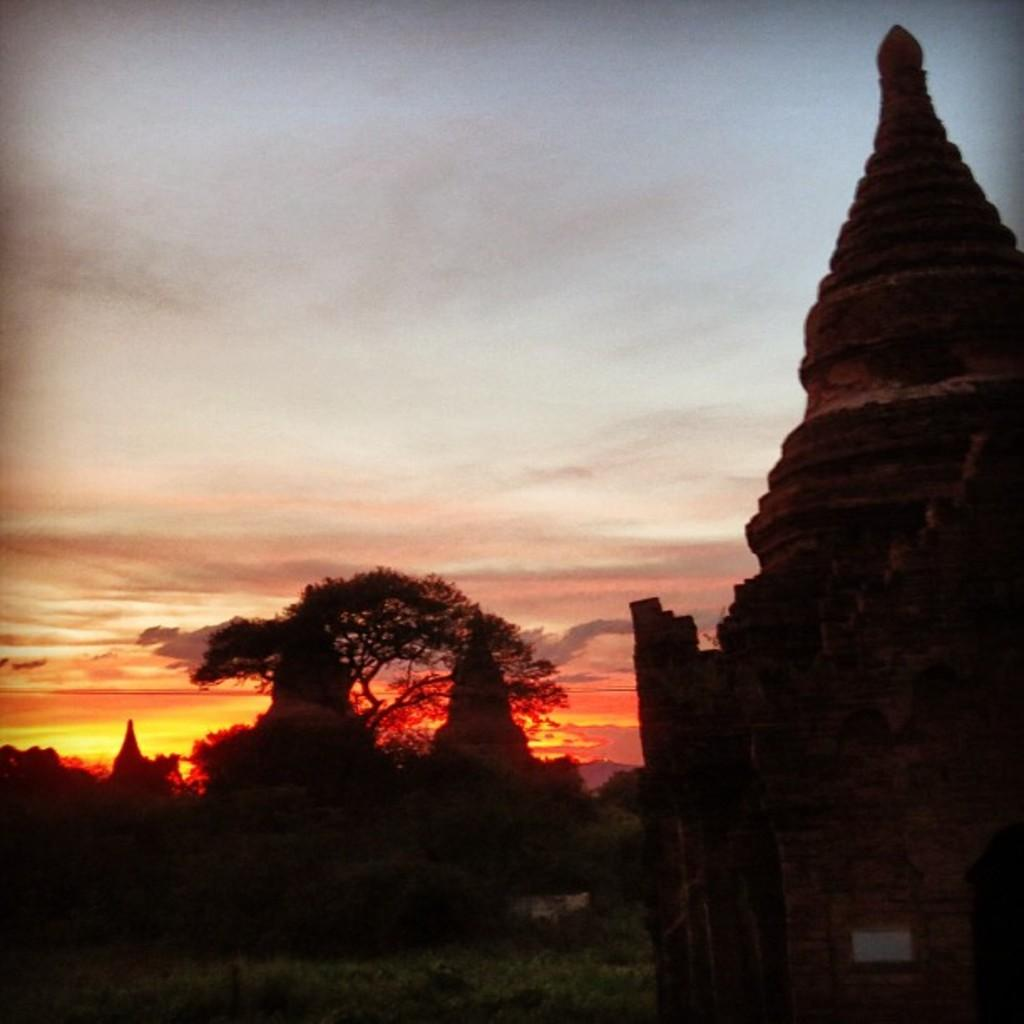What can be seen in the sky in the background of the image? There are clouds in the sky in the background of the image. What type of natural element is visible in the image? There is a tree visible in the image. What time of day does the image appear to be captured? The image appears to be captured during the evening. What type of architectural feature can be seen in the image? Domes are visible in the image. What type of pollution is visible in the image? There is no pollution visible in the image. What drug is being administered to the tree in the image? There is no drug being administered to the tree in the image; it is a natural element. 